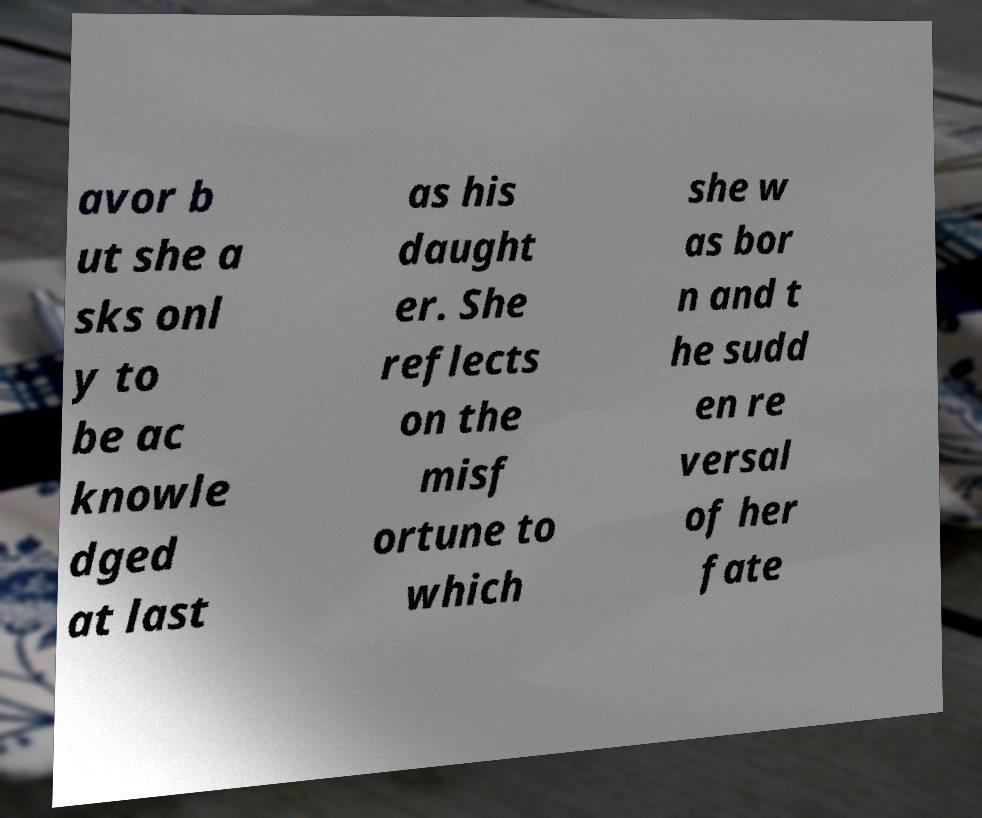Can you read and provide the text displayed in the image?This photo seems to have some interesting text. Can you extract and type it out for me? avor b ut she a sks onl y to be ac knowle dged at last as his daught er. She reflects on the misf ortune to which she w as bor n and t he sudd en re versal of her fate 